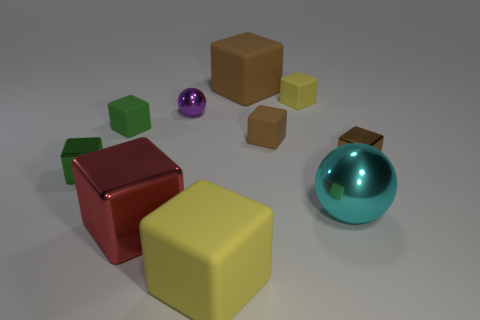How many tiny rubber cubes are on the right side of the sphere that is behind the small green object in front of the green matte thing? Upon close examination of the image, I can confirm that there are indeed two small rubber cubes situated to the right of the reflective sphere, which itself is positioned behind a small green cylindrical object, in front of a matte green cube. 